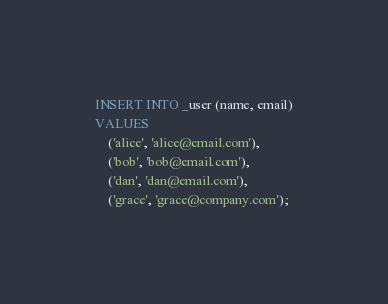Convert code to text. <code><loc_0><loc_0><loc_500><loc_500><_SQL_>INSERT INTO _user (name, email)
VALUES
    ('alice', 'alice@email.com'),
    ('bob', 'bob@email.com'),
    ('dan', 'dan@email.com'),
    ('grace', 'grace@company.com');
</code> 